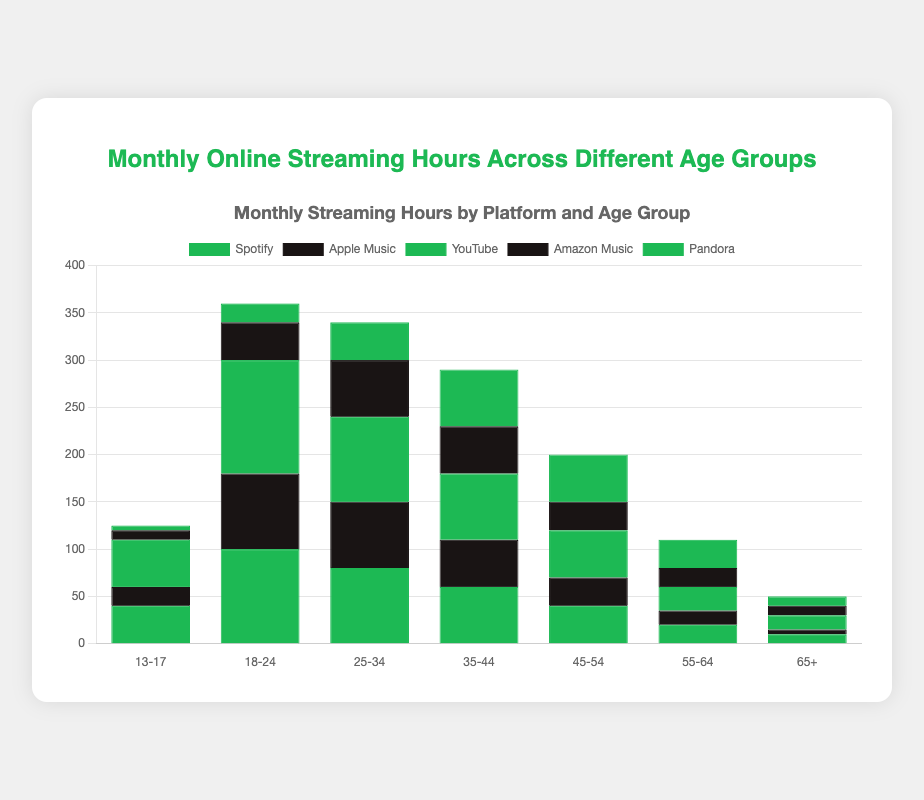What age group spends the most time streaming on Spotify? Look for the tallest bar in the section labeled "Spotify" and check its corresponding age group. The highest value is for the 18-24 age group.
Answer: 18-24 Between YouTube and Amazon Music, which platform has higher usage for the 25-34 age group? Compare the heights of the bars for YouTube and Amazon Music in the 25-34 age group. The YouTube bar is taller than the Amazon Music bar.
Answer: YouTube What is the total streaming hours for the 35-44 age group across all platforms? Sum the values for Spotify, Apple Music, YouTube, Amazon Music, and Pandora in the 35-44 age group: 60 + 50 + 70 + 50 + 60 = 290.
Answer: 290 Which platform shows a decrease in usage as age increases from 25-34 to 65+? Check the heights of bars for each platform from the 25-34 to 65+ age groups. Spotify, Apple Music, YouTube, Amazon Music, and Pandora all show a decrease.
Answer: All platforms How do the streaming hours of Spotify for the 13-17 age group compare with the Apple Music streaming hours for the same age group? Look at the heights of the bars for Spotify and Apple Music in the 13-17 age group. The Spotify bar is taller than the Apple Music bar.
Answer: Spotify What is the average monthly streaming hour for the 45-54 age group across all platforms? Calculate the sum of the streaming hours for all platforms in the 45-54 age group and then divide by the number of platforms: (40 + 30 + 50 + 30 + 50) / 5 = 40.
Answer: 40 Is the streaming hours of Pandora greater than Apple Music for the 55-64 age group? Compare the bar heights of Pandora and Apple Music in the 55-64 age group. The Pandora bar is taller.
Answer: Yes Which two age groups have the same streaming hours for Amazon Music? Identify the age groups with equal-height bars for Amazon Music. Both 13-17 and 65+ age groups have bars with a height of 10.
Answer: 13-17 and 65+ What is the sum of Spotify streaming hours for the age groups below 35? Add Spotify streaming hours for 13-17, 18-24, and 25-34: 40 + 100 + 80 = 220.
Answer: 220 What is the difference in streaming hours between YouTube and Pandora for the 35-44 age group? Subtract the Pandora streaming hours from YouTube in the 35-44 age group: 70 - 60 = 10.
Answer: 10 